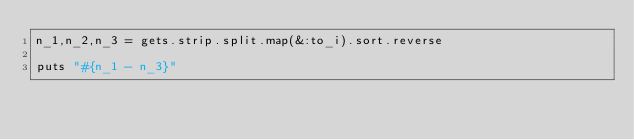<code> <loc_0><loc_0><loc_500><loc_500><_Ruby_>n_1,n_2,n_3 = gets.strip.split.map(&:to_i).sort.reverse

puts "#{n_1 - n_3}"</code> 